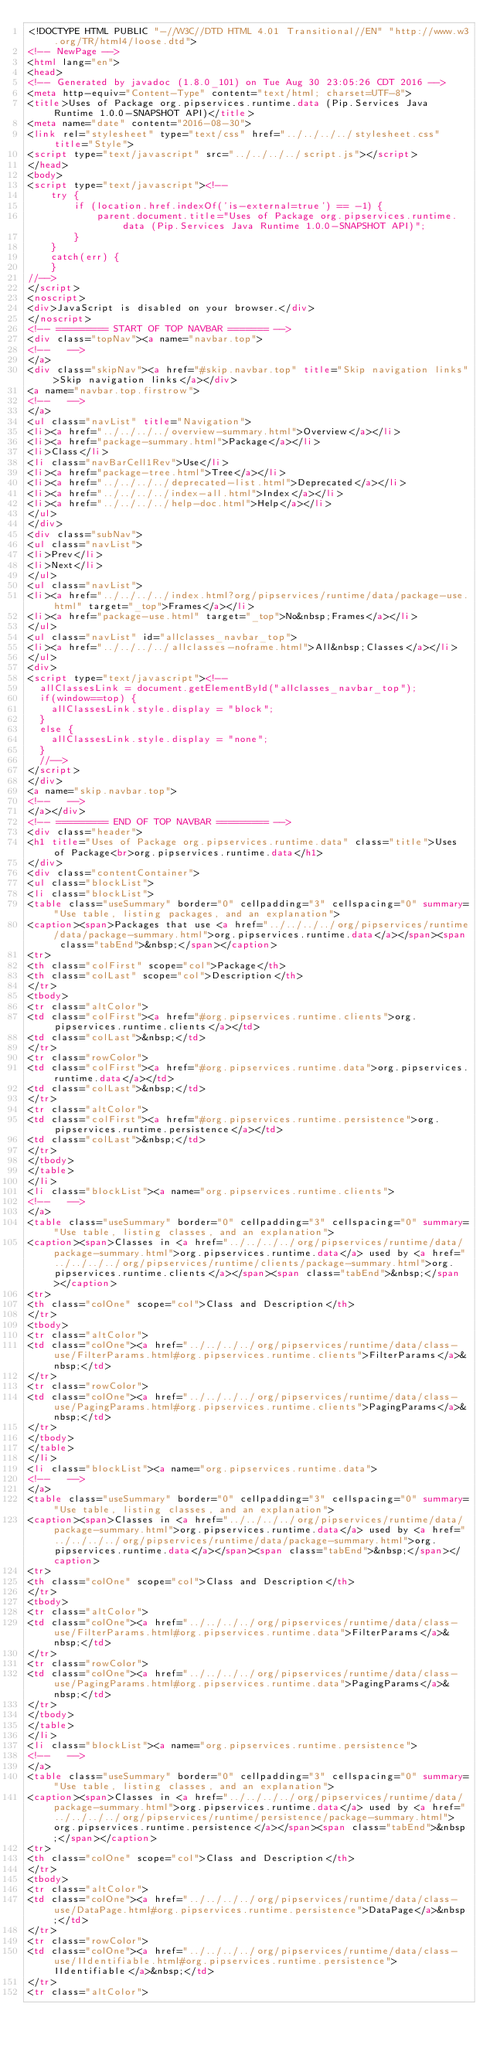Convert code to text. <code><loc_0><loc_0><loc_500><loc_500><_HTML_><!DOCTYPE HTML PUBLIC "-//W3C//DTD HTML 4.01 Transitional//EN" "http://www.w3.org/TR/html4/loose.dtd">
<!-- NewPage -->
<html lang="en">
<head>
<!-- Generated by javadoc (1.8.0_101) on Tue Aug 30 23:05:26 CDT 2016 -->
<meta http-equiv="Content-Type" content="text/html; charset=UTF-8">
<title>Uses of Package org.pipservices.runtime.data (Pip.Services Java Runtime 1.0.0-SNAPSHOT API)</title>
<meta name="date" content="2016-08-30">
<link rel="stylesheet" type="text/css" href="../../../../stylesheet.css" title="Style">
<script type="text/javascript" src="../../../../script.js"></script>
</head>
<body>
<script type="text/javascript"><!--
    try {
        if (location.href.indexOf('is-external=true') == -1) {
            parent.document.title="Uses of Package org.pipservices.runtime.data (Pip.Services Java Runtime 1.0.0-SNAPSHOT API)";
        }
    }
    catch(err) {
    }
//-->
</script>
<noscript>
<div>JavaScript is disabled on your browser.</div>
</noscript>
<!-- ========= START OF TOP NAVBAR ======= -->
<div class="topNav"><a name="navbar.top">
<!--   -->
</a>
<div class="skipNav"><a href="#skip.navbar.top" title="Skip navigation links">Skip navigation links</a></div>
<a name="navbar.top.firstrow">
<!--   -->
</a>
<ul class="navList" title="Navigation">
<li><a href="../../../../overview-summary.html">Overview</a></li>
<li><a href="package-summary.html">Package</a></li>
<li>Class</li>
<li class="navBarCell1Rev">Use</li>
<li><a href="package-tree.html">Tree</a></li>
<li><a href="../../../../deprecated-list.html">Deprecated</a></li>
<li><a href="../../../../index-all.html">Index</a></li>
<li><a href="../../../../help-doc.html">Help</a></li>
</ul>
</div>
<div class="subNav">
<ul class="navList">
<li>Prev</li>
<li>Next</li>
</ul>
<ul class="navList">
<li><a href="../../../../index.html?org/pipservices/runtime/data/package-use.html" target="_top">Frames</a></li>
<li><a href="package-use.html" target="_top">No&nbsp;Frames</a></li>
</ul>
<ul class="navList" id="allclasses_navbar_top">
<li><a href="../../../../allclasses-noframe.html">All&nbsp;Classes</a></li>
</ul>
<div>
<script type="text/javascript"><!--
  allClassesLink = document.getElementById("allclasses_navbar_top");
  if(window==top) {
    allClassesLink.style.display = "block";
  }
  else {
    allClassesLink.style.display = "none";
  }
  //-->
</script>
</div>
<a name="skip.navbar.top">
<!--   -->
</a></div>
<!-- ========= END OF TOP NAVBAR ========= -->
<div class="header">
<h1 title="Uses of Package org.pipservices.runtime.data" class="title">Uses of Package<br>org.pipservices.runtime.data</h1>
</div>
<div class="contentContainer">
<ul class="blockList">
<li class="blockList">
<table class="useSummary" border="0" cellpadding="3" cellspacing="0" summary="Use table, listing packages, and an explanation">
<caption><span>Packages that use <a href="../../../../org/pipservices/runtime/data/package-summary.html">org.pipservices.runtime.data</a></span><span class="tabEnd">&nbsp;</span></caption>
<tr>
<th class="colFirst" scope="col">Package</th>
<th class="colLast" scope="col">Description</th>
</tr>
<tbody>
<tr class="altColor">
<td class="colFirst"><a href="#org.pipservices.runtime.clients">org.pipservices.runtime.clients</a></td>
<td class="colLast">&nbsp;</td>
</tr>
<tr class="rowColor">
<td class="colFirst"><a href="#org.pipservices.runtime.data">org.pipservices.runtime.data</a></td>
<td class="colLast">&nbsp;</td>
</tr>
<tr class="altColor">
<td class="colFirst"><a href="#org.pipservices.runtime.persistence">org.pipservices.runtime.persistence</a></td>
<td class="colLast">&nbsp;</td>
</tr>
</tbody>
</table>
</li>
<li class="blockList"><a name="org.pipservices.runtime.clients">
<!--   -->
</a>
<table class="useSummary" border="0" cellpadding="3" cellspacing="0" summary="Use table, listing classes, and an explanation">
<caption><span>Classes in <a href="../../../../org/pipservices/runtime/data/package-summary.html">org.pipservices.runtime.data</a> used by <a href="../../../../org/pipservices/runtime/clients/package-summary.html">org.pipservices.runtime.clients</a></span><span class="tabEnd">&nbsp;</span></caption>
<tr>
<th class="colOne" scope="col">Class and Description</th>
</tr>
<tbody>
<tr class="altColor">
<td class="colOne"><a href="../../../../org/pipservices/runtime/data/class-use/FilterParams.html#org.pipservices.runtime.clients">FilterParams</a>&nbsp;</td>
</tr>
<tr class="rowColor">
<td class="colOne"><a href="../../../../org/pipservices/runtime/data/class-use/PagingParams.html#org.pipservices.runtime.clients">PagingParams</a>&nbsp;</td>
</tr>
</tbody>
</table>
</li>
<li class="blockList"><a name="org.pipservices.runtime.data">
<!--   -->
</a>
<table class="useSummary" border="0" cellpadding="3" cellspacing="0" summary="Use table, listing classes, and an explanation">
<caption><span>Classes in <a href="../../../../org/pipservices/runtime/data/package-summary.html">org.pipservices.runtime.data</a> used by <a href="../../../../org/pipservices/runtime/data/package-summary.html">org.pipservices.runtime.data</a></span><span class="tabEnd">&nbsp;</span></caption>
<tr>
<th class="colOne" scope="col">Class and Description</th>
</tr>
<tbody>
<tr class="altColor">
<td class="colOne"><a href="../../../../org/pipservices/runtime/data/class-use/FilterParams.html#org.pipservices.runtime.data">FilterParams</a>&nbsp;</td>
</tr>
<tr class="rowColor">
<td class="colOne"><a href="../../../../org/pipservices/runtime/data/class-use/PagingParams.html#org.pipservices.runtime.data">PagingParams</a>&nbsp;</td>
</tr>
</tbody>
</table>
</li>
<li class="blockList"><a name="org.pipservices.runtime.persistence">
<!--   -->
</a>
<table class="useSummary" border="0" cellpadding="3" cellspacing="0" summary="Use table, listing classes, and an explanation">
<caption><span>Classes in <a href="../../../../org/pipservices/runtime/data/package-summary.html">org.pipservices.runtime.data</a> used by <a href="../../../../org/pipservices/runtime/persistence/package-summary.html">org.pipservices.runtime.persistence</a></span><span class="tabEnd">&nbsp;</span></caption>
<tr>
<th class="colOne" scope="col">Class and Description</th>
</tr>
<tbody>
<tr class="altColor">
<td class="colOne"><a href="../../../../org/pipservices/runtime/data/class-use/DataPage.html#org.pipservices.runtime.persistence">DataPage</a>&nbsp;</td>
</tr>
<tr class="rowColor">
<td class="colOne"><a href="../../../../org/pipservices/runtime/data/class-use/IIdentifiable.html#org.pipservices.runtime.persistence">IIdentifiable</a>&nbsp;</td>
</tr>
<tr class="altColor"></code> 